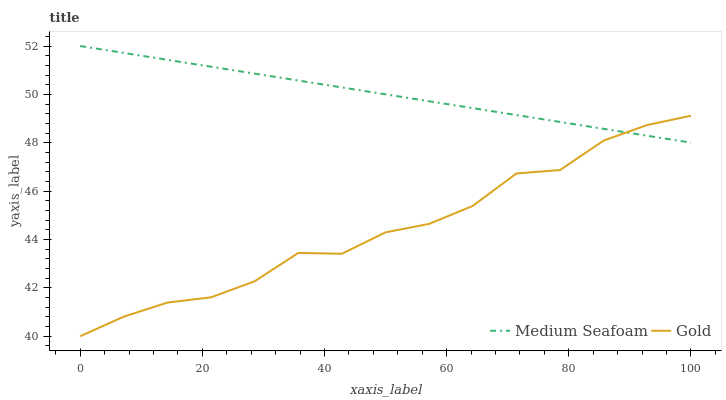Does Gold have the minimum area under the curve?
Answer yes or no. Yes. Does Medium Seafoam have the maximum area under the curve?
Answer yes or no. Yes. Does Gold have the maximum area under the curve?
Answer yes or no. No. Is Medium Seafoam the smoothest?
Answer yes or no. Yes. Is Gold the roughest?
Answer yes or no. Yes. Is Gold the smoothest?
Answer yes or no. No. Does Gold have the lowest value?
Answer yes or no. Yes. Does Medium Seafoam have the highest value?
Answer yes or no. Yes. Does Gold have the highest value?
Answer yes or no. No. Does Medium Seafoam intersect Gold?
Answer yes or no. Yes. Is Medium Seafoam less than Gold?
Answer yes or no. No. Is Medium Seafoam greater than Gold?
Answer yes or no. No. 